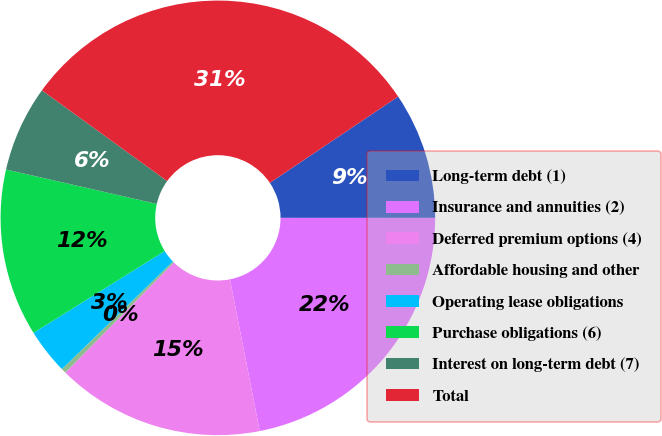<chart> <loc_0><loc_0><loc_500><loc_500><pie_chart><fcel>Long-term debt (1)<fcel>Insurance and annuities (2)<fcel>Deferred premium options (4)<fcel>Affordable housing and other<fcel>Operating lease obligations<fcel>Purchase obligations (6)<fcel>Interest on long-term debt (7)<fcel>Total<nl><fcel>9.43%<fcel>21.91%<fcel>15.47%<fcel>0.36%<fcel>3.38%<fcel>12.45%<fcel>6.41%<fcel>30.59%<nl></chart> 